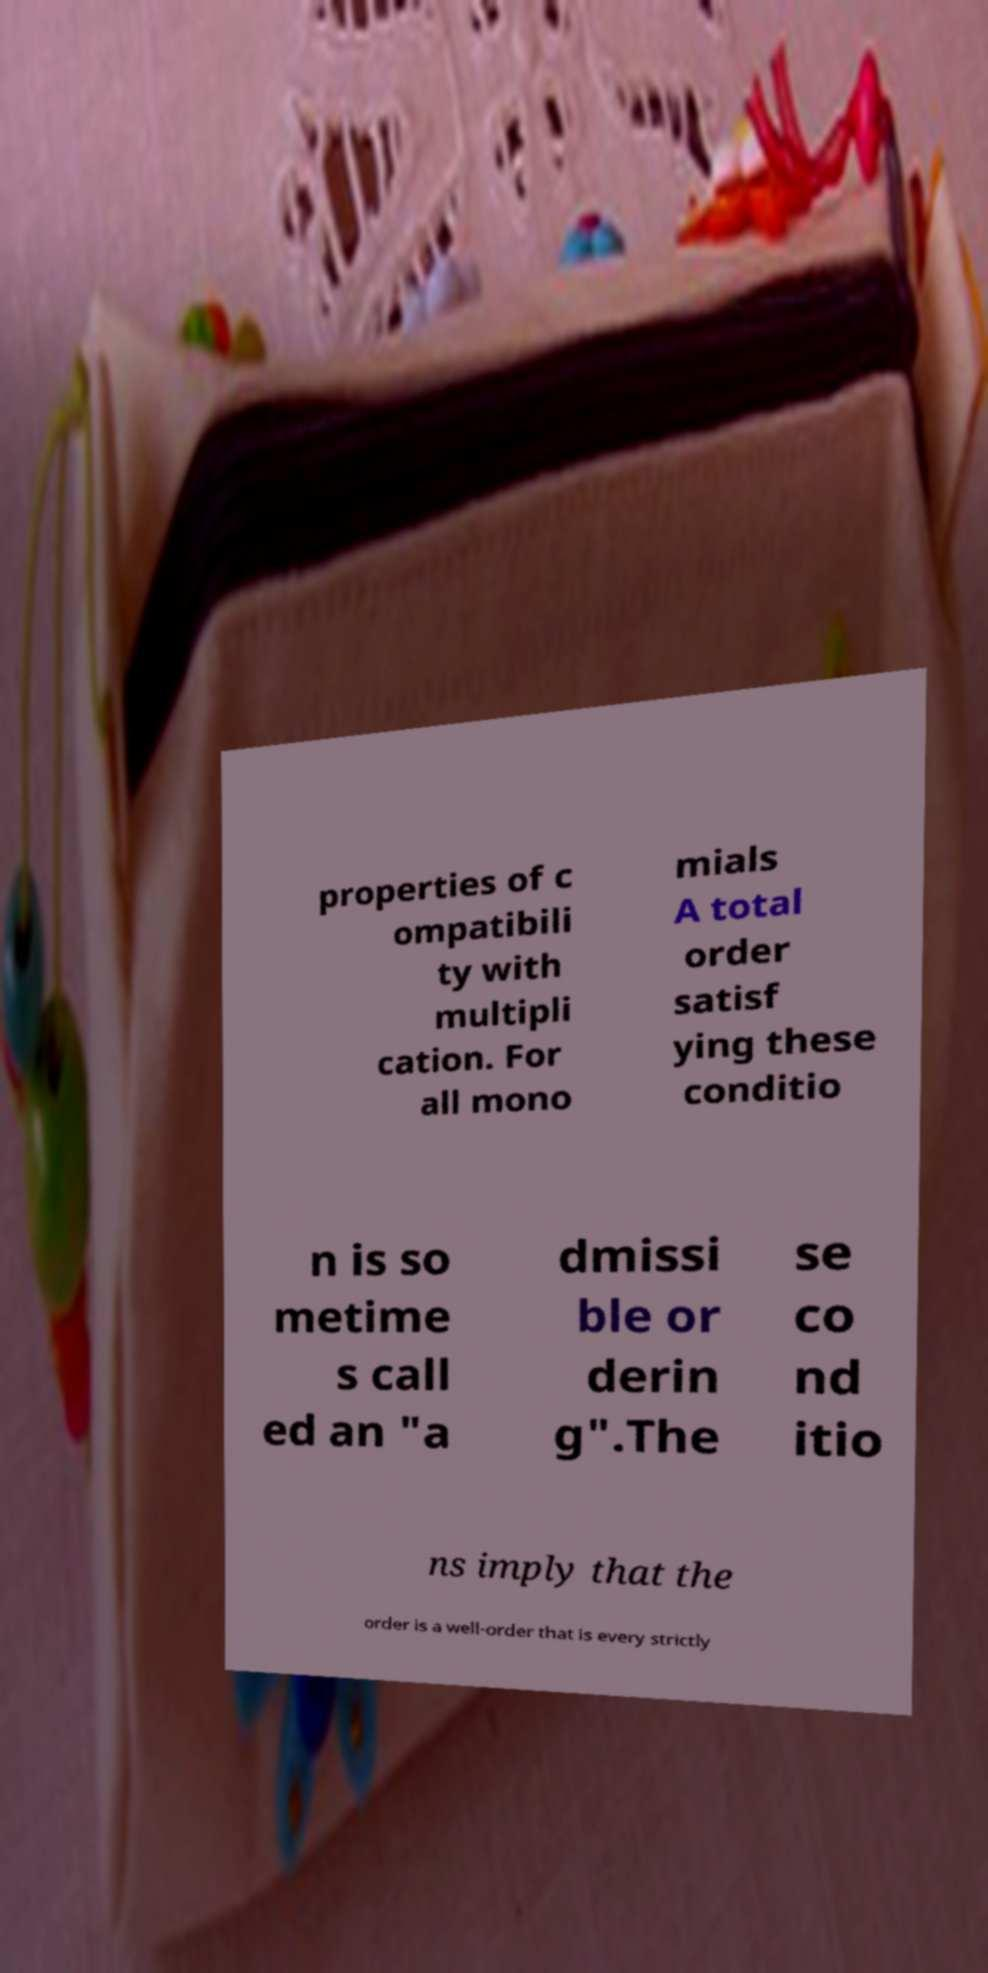There's text embedded in this image that I need extracted. Can you transcribe it verbatim? properties of c ompatibili ty with multipli cation. For all mono mials A total order satisf ying these conditio n is so metime s call ed an "a dmissi ble or derin g".The se co nd itio ns imply that the order is a well-order that is every strictly 